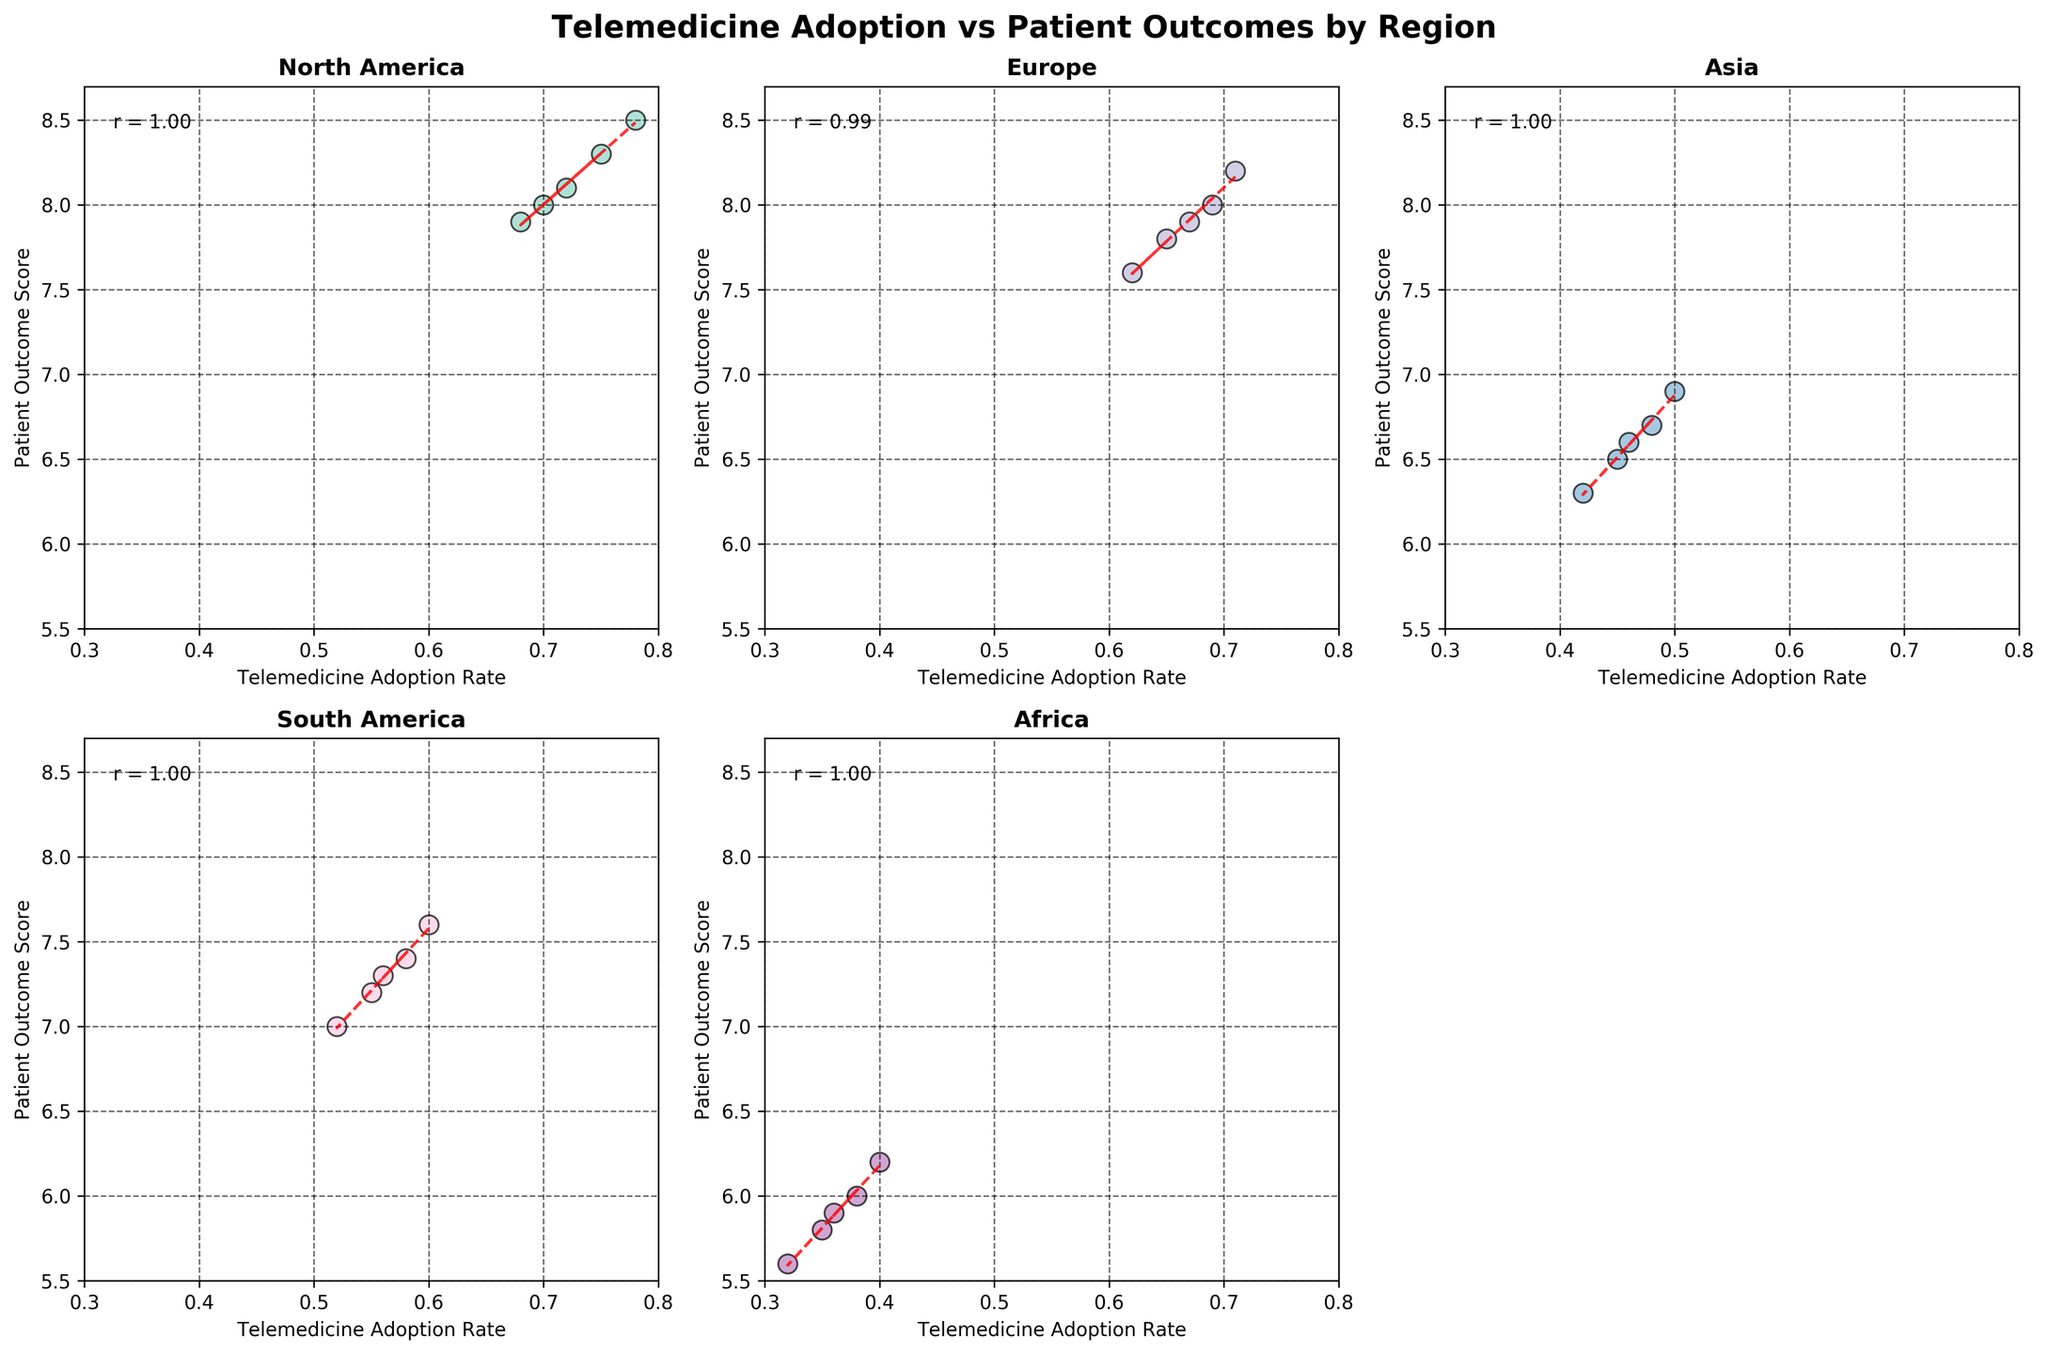Which region has the highest telemedicine adoption rate? By looking at the scatter plots, the region with the highest telemedicine adoption rate is North America, with adoption rates reaching up to 0.78.
Answer: North America Which region shows the lowest patient outcome scores? By referring to the y-axes of the plots, the region with the lowest patient outcome scores is Africa, with scores going as low as 5.6.
Answer: Africa Is there a positive correlation between telemedicine adoption and patient outcomes in Europe? The scatter plot for Europe shows an upward trend line, and the correlation coefficient (r) is shown as positive. This indicates a positive correlation.
Answer: Yes Which region has the least variability in telemedicine adoption rates? By looking at the spread of data points on the x-axis for each subplot, North America has the least spread in telemedicine adoption rates, ranging narrowly from 0.68 to 0.78.
Answer: North America Compare the correlation coefficients between North America and Asia. Which region has a stronger correlation? From the annotated correlation coefficients on the scatter plots, North America has an r value higher than Asia, indicating that North America has a stronger correlation.
Answer: North America What is the general trend depicted in the Oceania region's scatter plot? The scatter plot for Oceania shows an upward-sloping trend line, indicating a positive relationship between telemedicine adoption rates and patient outcome scores.
Answer: Upward What is the range of patient outcome scores for South America? By observing the y-axis for the South America subplot, the patient outcome scores range from 7.0 to 7.6.
Answer: 7.0 to 7.6 How do patient outcome scores in South America compare to those in Africa? South America’s patient outcome scores range from 7.0 to 7.6, while Africa’s range from 5.6 to 6.2. Therefore, South America generally has higher patient outcome scores compared to Africa.
Answer: South America has higher scores Which region shows data points closest to the maximum x-axis limit of 0.8? The scatter plot for North America shows data points that are closest to the maximum x-axis limit of 0.8, specifically around 0.78.
Answer: North America 